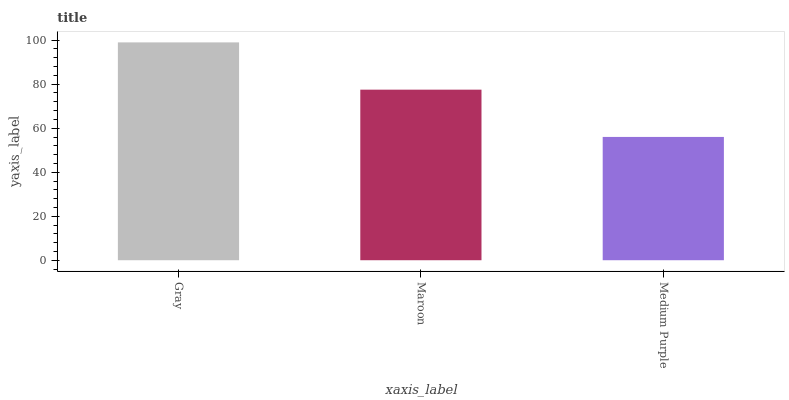Is Medium Purple the minimum?
Answer yes or no. Yes. Is Gray the maximum?
Answer yes or no. Yes. Is Maroon the minimum?
Answer yes or no. No. Is Maroon the maximum?
Answer yes or no. No. Is Gray greater than Maroon?
Answer yes or no. Yes. Is Maroon less than Gray?
Answer yes or no. Yes. Is Maroon greater than Gray?
Answer yes or no. No. Is Gray less than Maroon?
Answer yes or no. No. Is Maroon the high median?
Answer yes or no. Yes. Is Maroon the low median?
Answer yes or no. Yes. Is Gray the high median?
Answer yes or no. No. Is Medium Purple the low median?
Answer yes or no. No. 